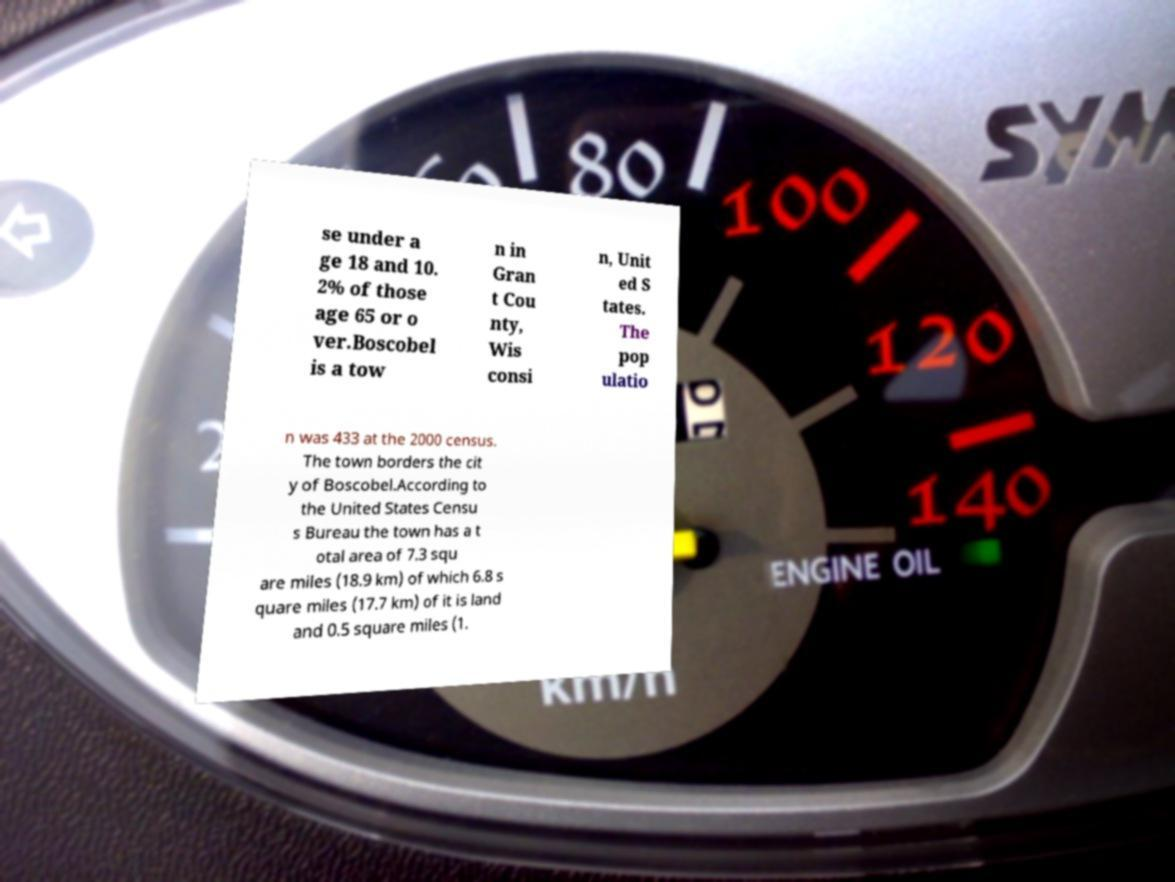Could you extract and type out the text from this image? se under a ge 18 and 10. 2% of those age 65 or o ver.Boscobel is a tow n in Gran t Cou nty, Wis consi n, Unit ed S tates. The pop ulatio n was 433 at the 2000 census. The town borders the cit y of Boscobel.According to the United States Censu s Bureau the town has a t otal area of 7.3 squ are miles (18.9 km) of which 6.8 s quare miles (17.7 km) of it is land and 0.5 square miles (1. 